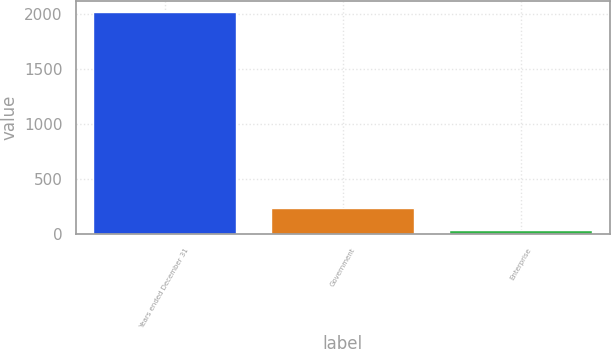Convert chart to OTSL. <chart><loc_0><loc_0><loc_500><loc_500><bar_chart><fcel>Years ended December 31<fcel>Government<fcel>Enterprise<nl><fcel>2011<fcel>234.4<fcel>37<nl></chart> 